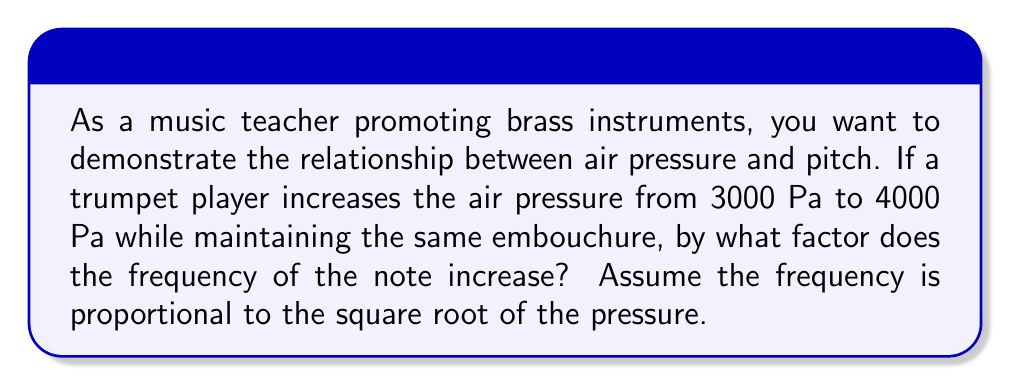Help me with this question. Let's approach this step-by-step:

1) We're given that frequency ($f$) is proportional to the square root of pressure ($P$):

   $f \propto \sqrt{P}$

2) We can express this as an equation with a constant $k$:

   $f = k\sqrt{P}$

3) Let $f_1$ and $P_1$ be the initial frequency and pressure, and $f_2$ and $P_2$ be the final frequency and pressure:

   $f_1 = k\sqrt{P_1}$
   $f_2 = k\sqrt{P_2}$

4) We want to find the ratio $\frac{f_2}{f_1}$:

   $$\frac{f_2}{f_1} = \frac{k\sqrt{P_2}}{k\sqrt{P_1}}$$

5) The constant $k$ cancels out:

   $$\frac{f_2}{f_1} = \frac{\sqrt{P_2}}{\sqrt{P_1}} = \sqrt{\frac{P_2}{P_1}}$$

6) Now we can plug in our values:
   $P_1 = 3000$ Pa
   $P_2 = 4000$ Pa

   $$\frac{f_2}{f_1} = \sqrt{\frac{4000}{3000}} = \sqrt{\frac{4}{3}} \approx 1.1547$$

7) Therefore, the frequency increases by a factor of $\sqrt{\frac{4}{3}}$.
Answer: $\sqrt{\frac{4}{3}}$ 